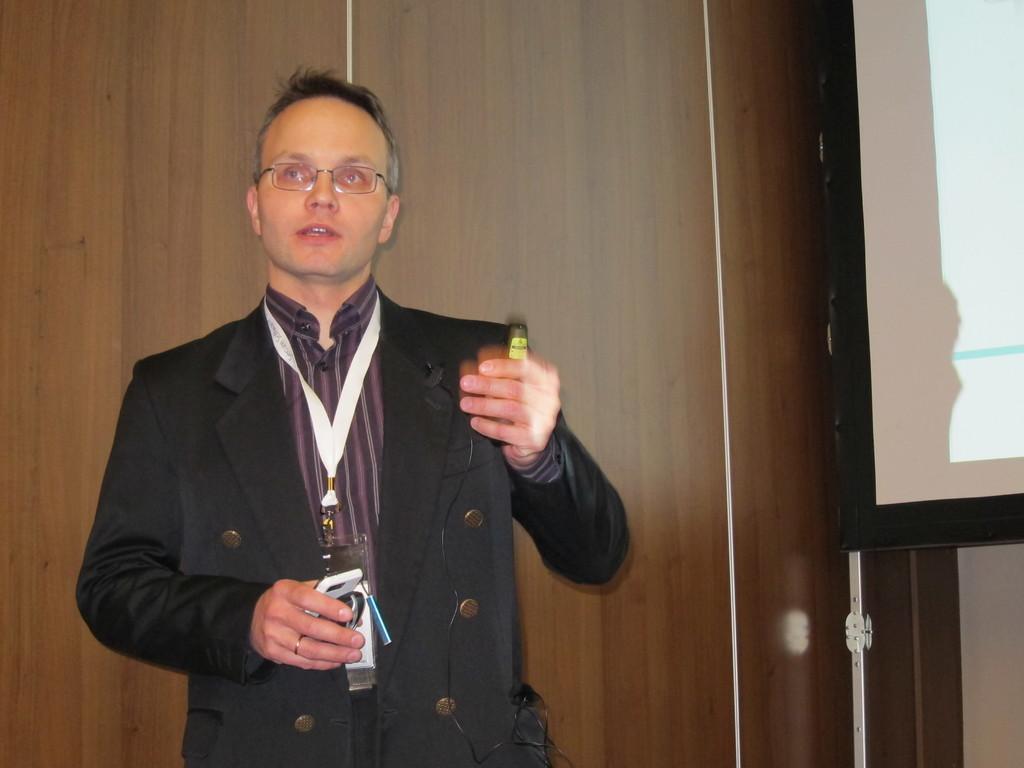Can you describe this image briefly? In this image, I can see a man standing and holding objects. On the right side of the image, there is a screen. In the background, I can see a wooden wall. 